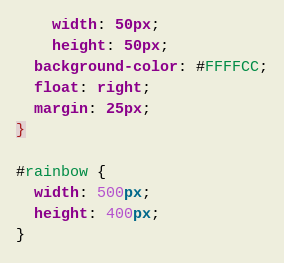Convert code to text. <code><loc_0><loc_0><loc_500><loc_500><_CSS_>	width: 50px;
	height: 50px;
  background-color: #FFFFCC;
  float: right;
  margin: 25px;
}

#rainbow {
  width: 500px;
  height: 400px;
}
</code> 